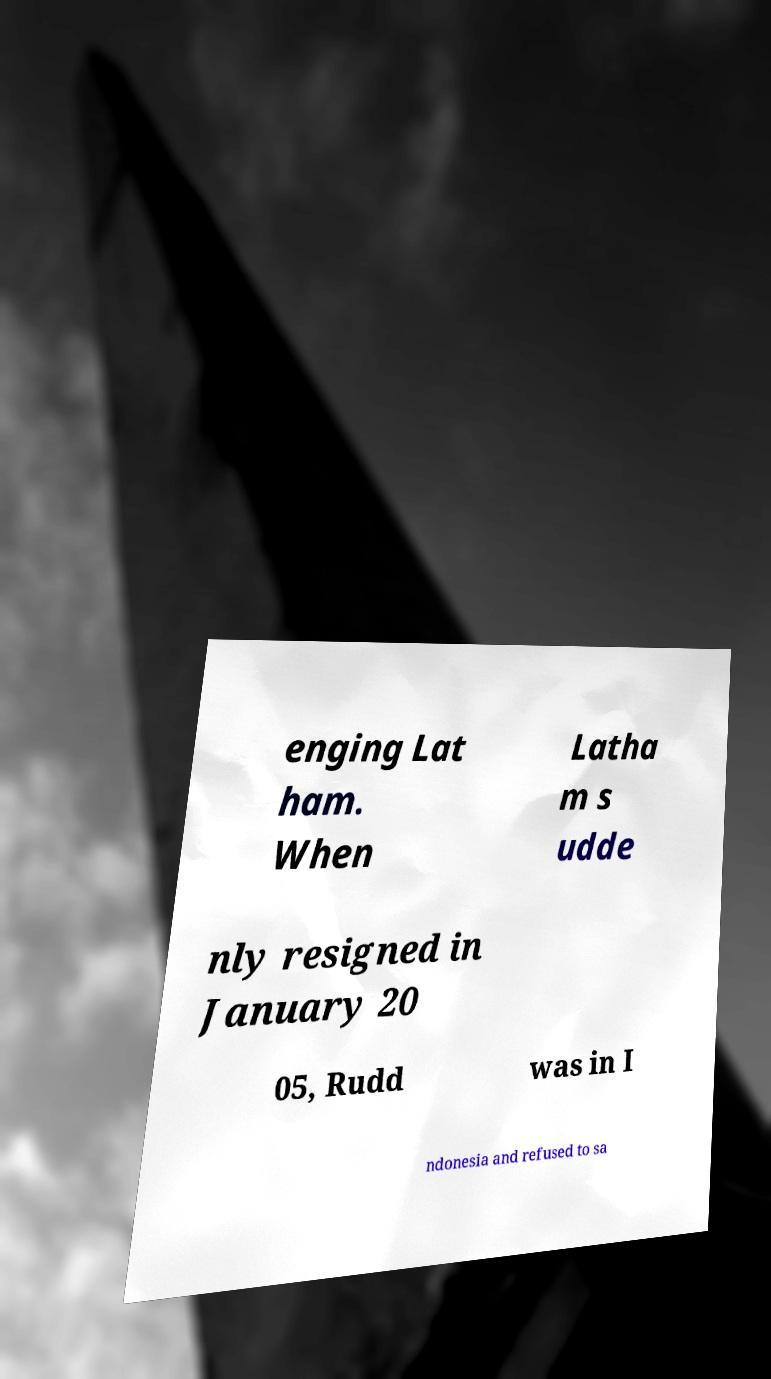I need the written content from this picture converted into text. Can you do that? enging Lat ham. When Latha m s udde nly resigned in January 20 05, Rudd was in I ndonesia and refused to sa 